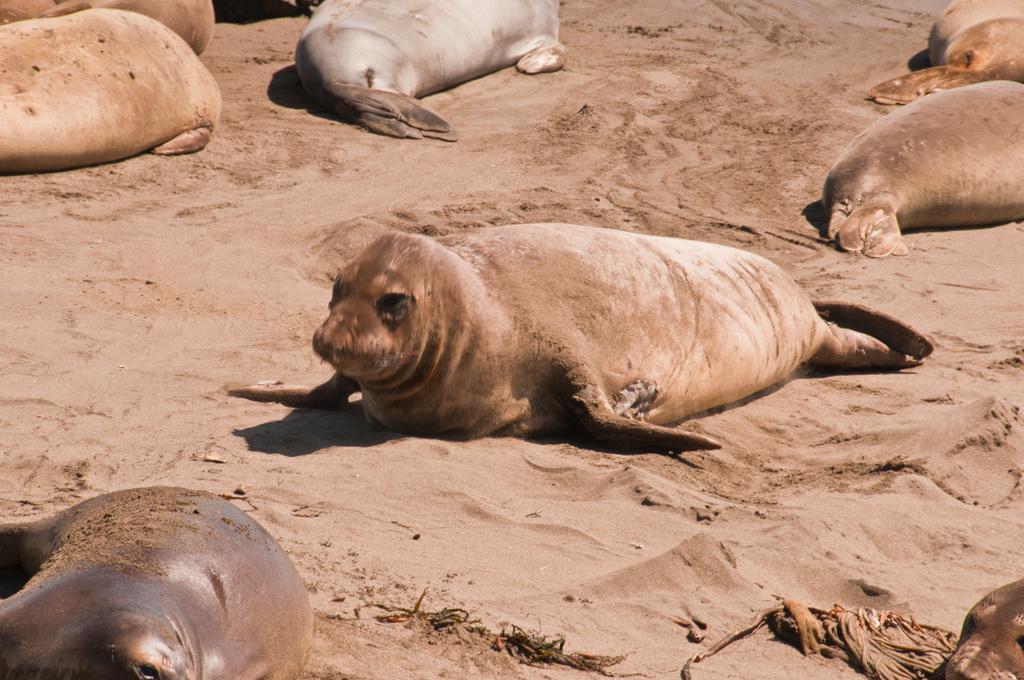Can you describe this image briefly? In this picture we see many seals on the sand. 